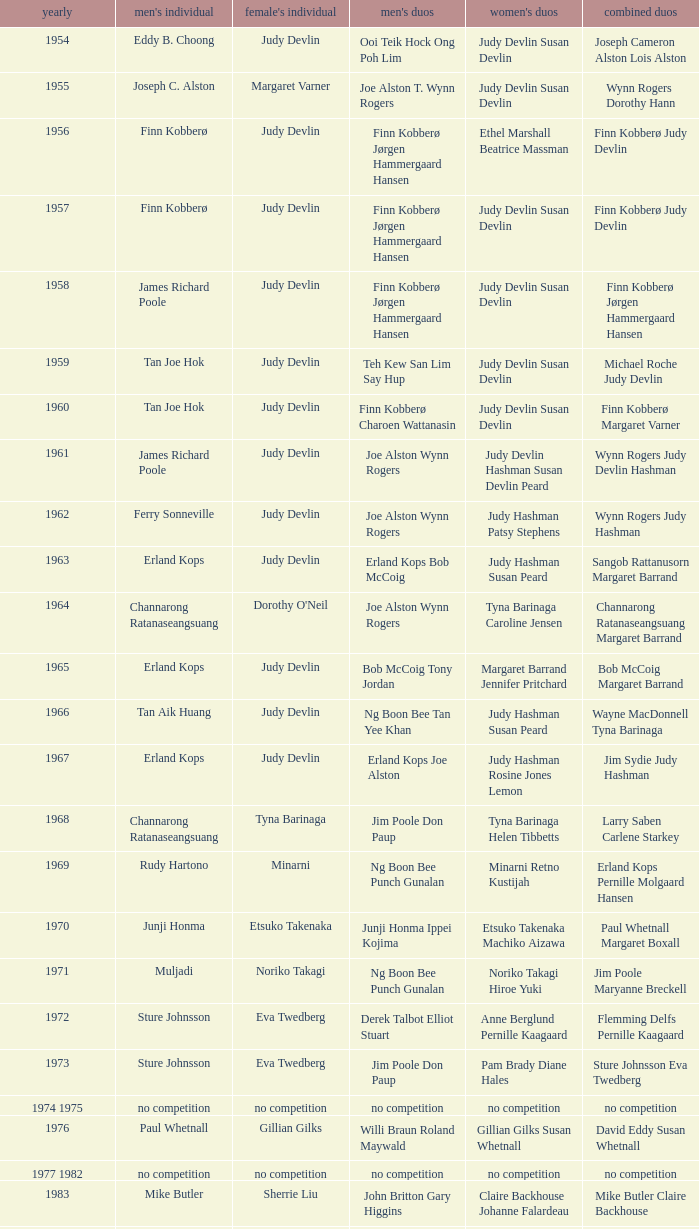Who was the women's singles champion in 1984? Luo Yun. 